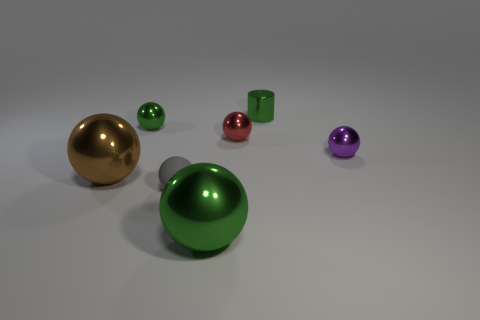Is there anything else that is the same color as the tiny cylinder?
Make the answer very short. Yes. There is a tiny object that is both in front of the red ball and behind the brown object; what is its color?
Your answer should be very brief. Purple. There is a green metallic sphere behind the matte sphere; does it have the same size as the large green metal thing?
Your answer should be very brief. No. Are there more small green things behind the gray matte sphere than small yellow metal cylinders?
Give a very brief answer. Yes. Is the shape of the purple object the same as the red shiny object?
Offer a very short reply. Yes. What size is the red shiny thing?
Provide a short and direct response. Small. Are there more purple things that are in front of the small red sphere than objects that are to the left of the brown sphere?
Your answer should be compact. Yes. There is a rubber ball; are there any green metal objects in front of it?
Give a very brief answer. Yes. Are there any green spheres that have the same size as the metallic cylinder?
Offer a terse response. Yes. There is a cylinder that is the same material as the red thing; what is its color?
Offer a terse response. Green. 